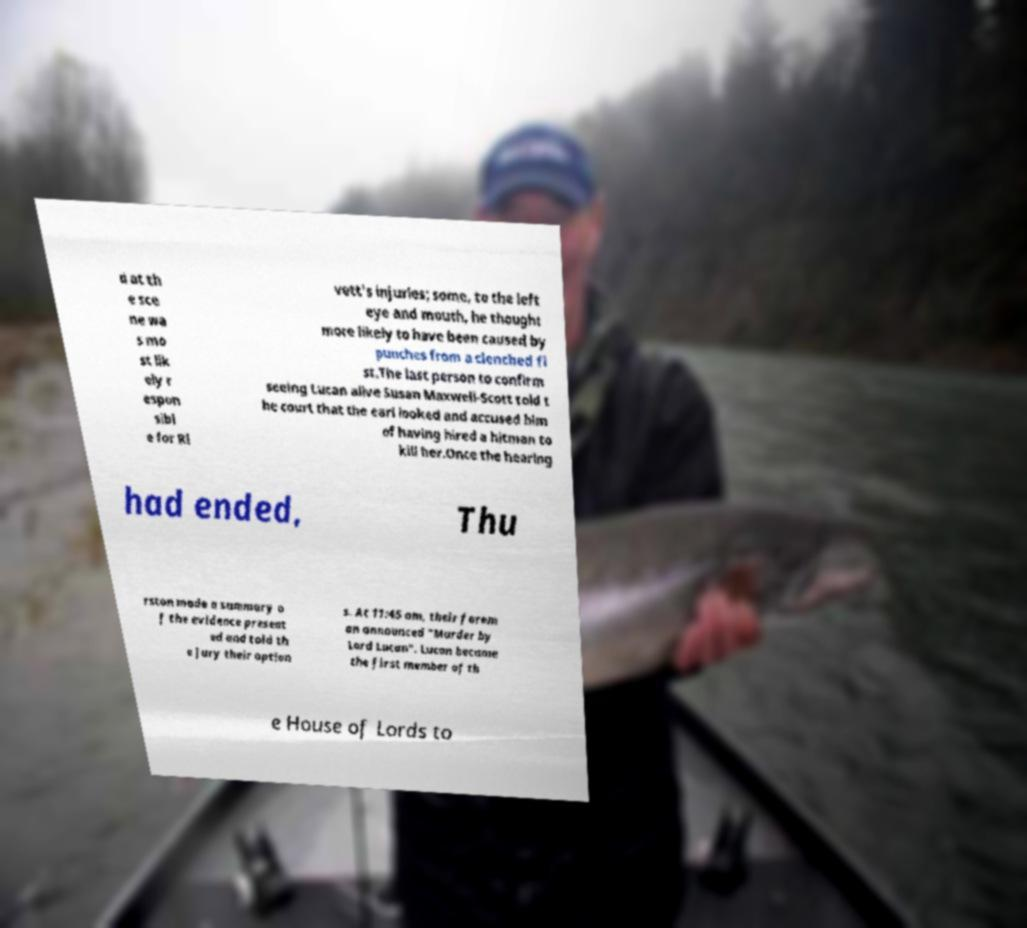Please identify and transcribe the text found in this image. d at th e sce ne wa s mo st lik ely r espon sibl e for Ri vett's injuries; some, to the left eye and mouth, he thought more likely to have been caused by punches from a clenched fi st.The last person to confirm seeing Lucan alive Susan Maxwell-Scott told t he court that the earl looked and accused him of having hired a hitman to kill her.Once the hearing had ended, Thu rston made a summary o f the evidence present ed and told th e jury their option s. At 11:45 am, their forem an announced "Murder by Lord Lucan". Lucan became the first member of th e House of Lords to 